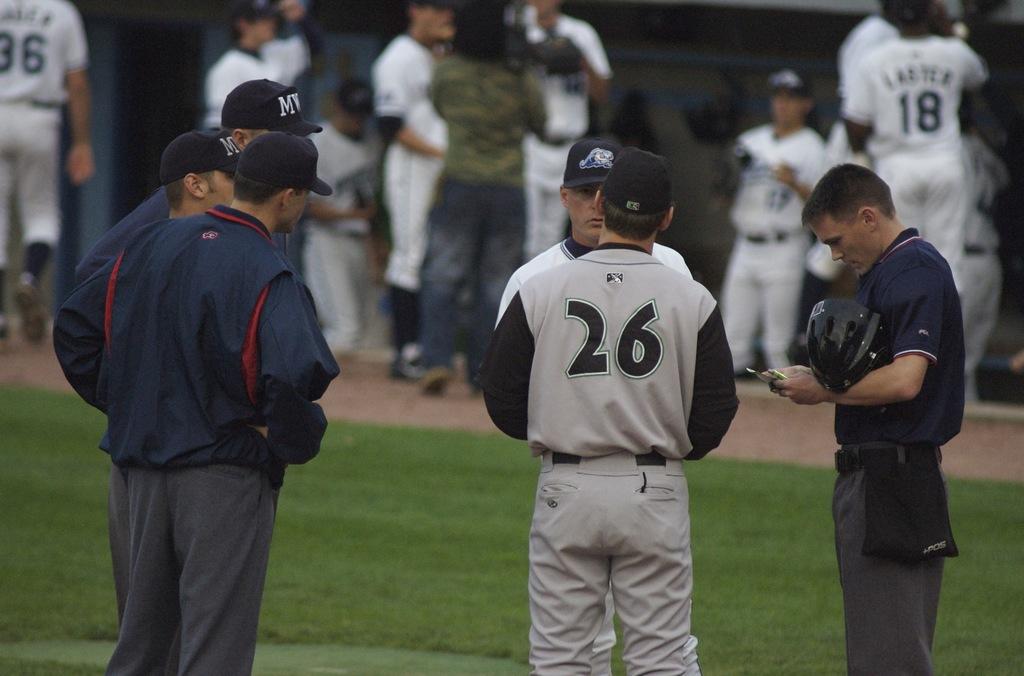What number is the player in the foreground?
Ensure brevity in your answer.  26. What number is the player on the top right in the background?
Your answer should be compact. 18. 